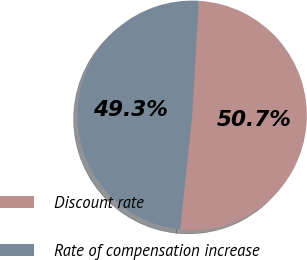Convert chart. <chart><loc_0><loc_0><loc_500><loc_500><pie_chart><fcel>Discount rate<fcel>Rate of compensation increase<nl><fcel>50.74%<fcel>49.26%<nl></chart> 